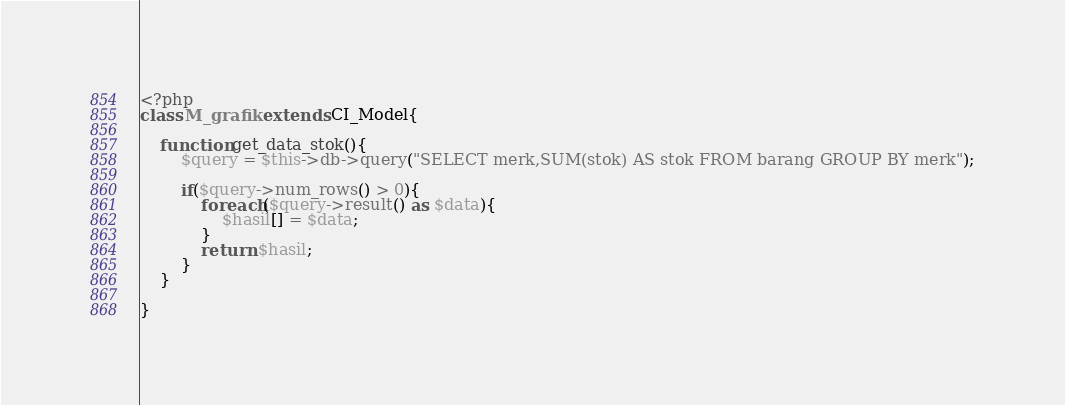<code> <loc_0><loc_0><loc_500><loc_500><_PHP_><?php
class M_grafik extends CI_Model{
 
    function get_data_stok(){
        $query = $this->db->query("SELECT merk,SUM(stok) AS stok FROM barang GROUP BY merk");
          
        if($query->num_rows() > 0){
            foreach($query->result() as $data){
                $hasil[] = $data;
            }
            return $hasil;
        }
    }
 
}</code> 